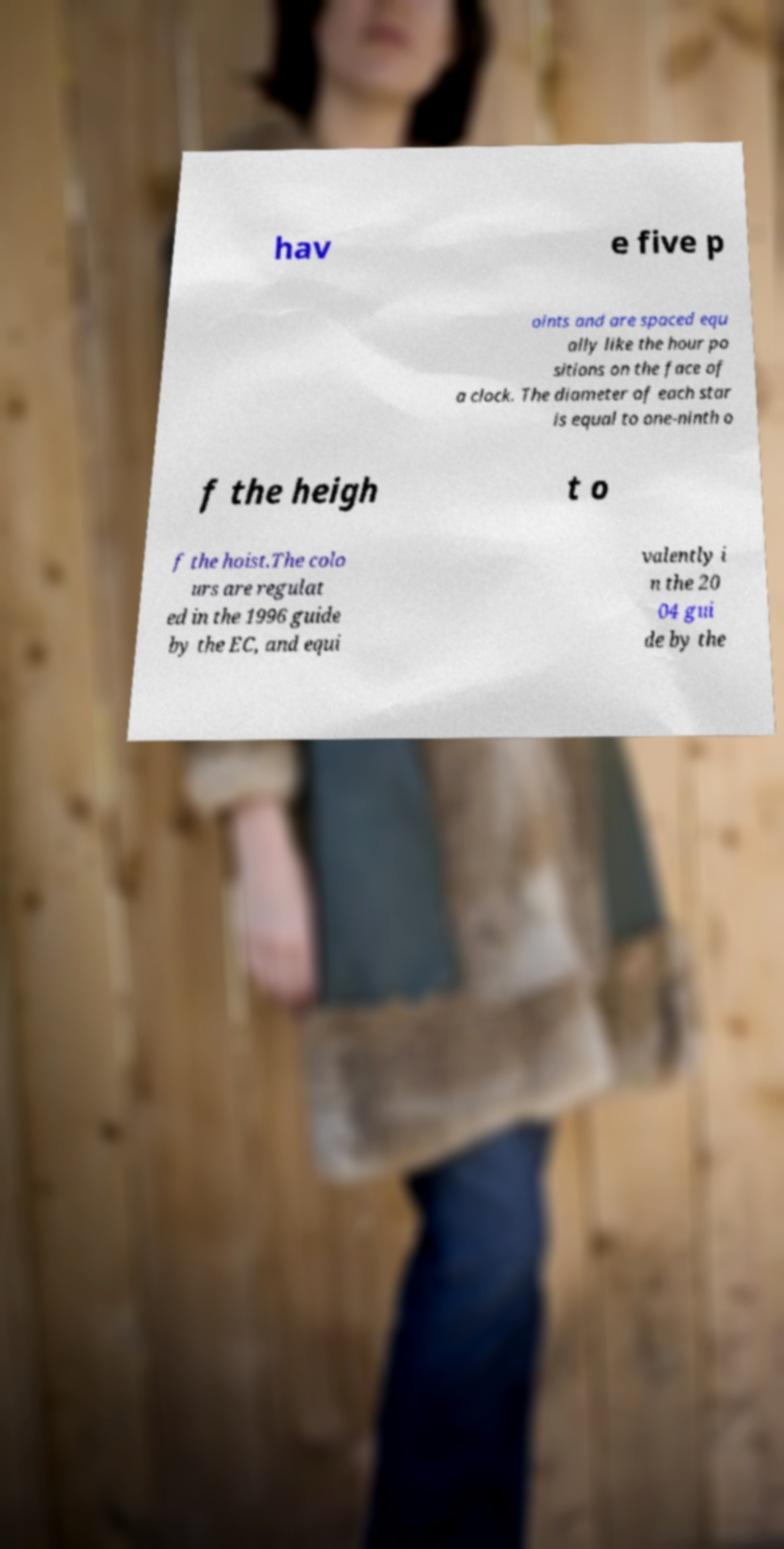Can you accurately transcribe the text from the provided image for me? hav e five p oints and are spaced equ ally like the hour po sitions on the face of a clock. The diameter of each star is equal to one-ninth o f the heigh t o f the hoist.The colo urs are regulat ed in the 1996 guide by the EC, and equi valently i n the 20 04 gui de by the 